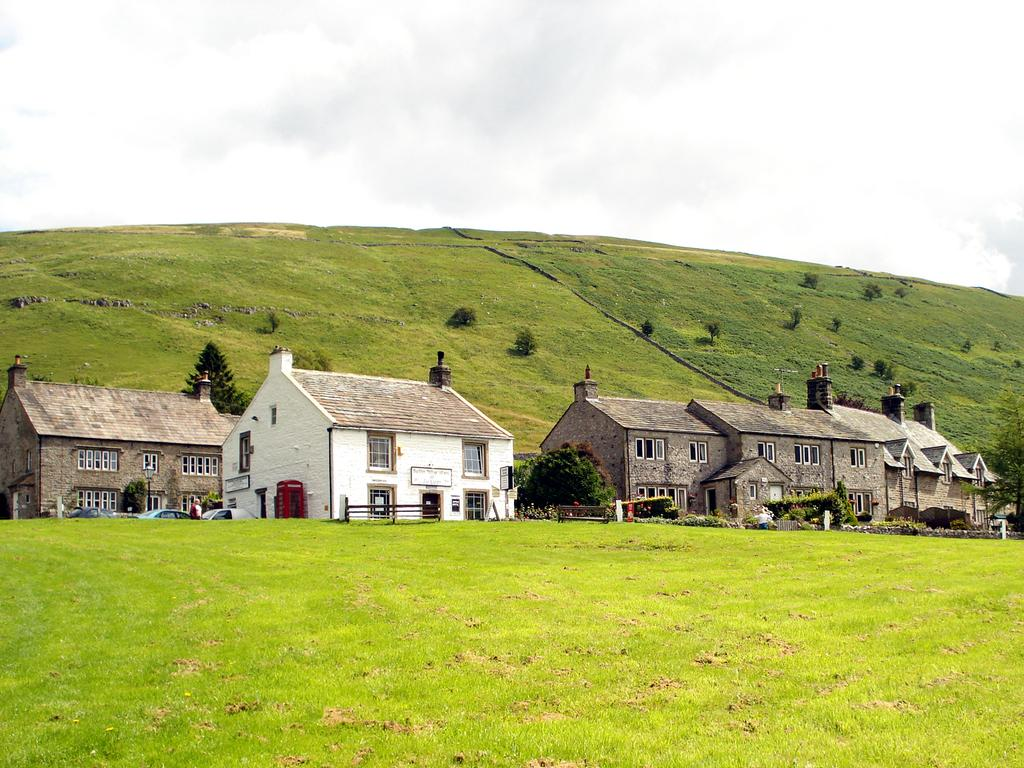What type of outdoor space is depicted in the image? There is a garden in the image. What structures can be seen in the garden? There are houses in the middle of the image. What type of good-bye is being said in the image? There is no indication of anyone saying good-bye in the image. What type of rest can be seen in the image? There is no rest or resting area visible in the image. 